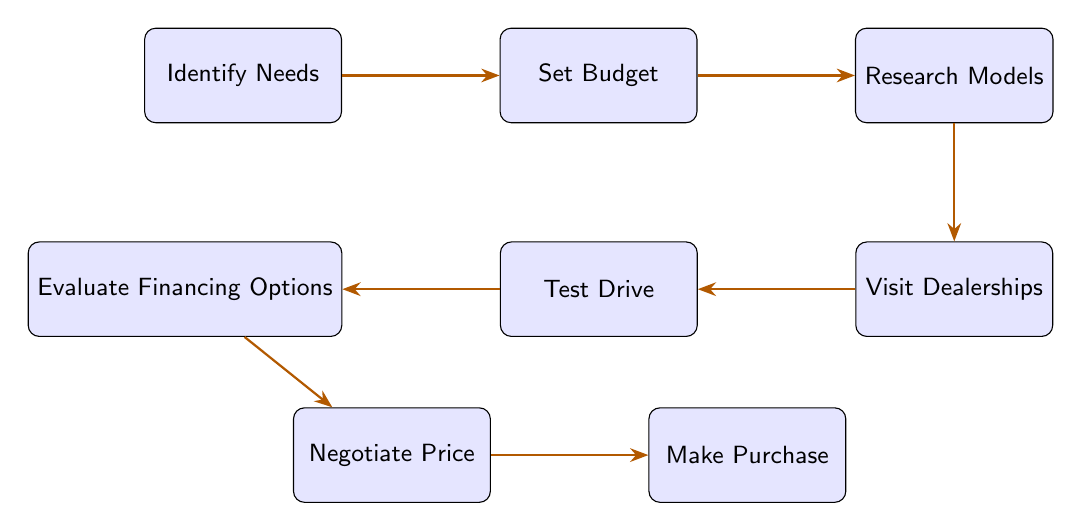What is the first step in the flow chart? The first node in the diagram is labeled "Identify Needs," indicating that this is the initial action in the decision-making process for buying a new car.
Answer: Identify Needs How many nodes are in the diagram? The diagram lists eight nodes, each representing a different step in the car-buying process.
Answer: 8 What comes after "Set Budget"? According to the flow of the diagram, the next step after "Set Budget" is "Research Models," indicating the sequence of actions.
Answer: Research Models Which step involves assessing comfort and performance? The node labeled "Test Drive" specifically describes the action of taking various cars for a test drive to evaluate comfort and performance.
Answer: Test Drive What are the last two steps in the decision-making process? The last two nodes in the flow chart are "Negotiate Price" followed by "Make Purchase," signifying the final steps in buying a car.
Answer: Negotiate Price, Make Purchase What is the relationship between "Research Models" and "Visit Dealerships"? "Research Models" leads directly to "Visit Dealerships," indicating that after researching models, the next logical step is to visit dealerships to see the cars.
Answer: Directly Connected What should you do before visiting dealerships? Before visiting dealerships, you need to "Research Models," which involves looking for car models that fit your needs and budget.
Answer: Research Models How many edges connect the nodes in the diagram? Each directional connection between the nodes is represented by an edge, and there are seven edges that link the eight nodes shown in the diagram.
Answer: 7 